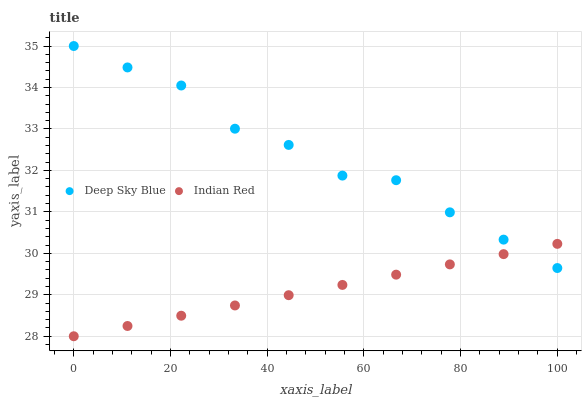Does Indian Red have the minimum area under the curve?
Answer yes or no. Yes. Does Deep Sky Blue have the maximum area under the curve?
Answer yes or no. Yes. Does Deep Sky Blue have the minimum area under the curve?
Answer yes or no. No. Is Indian Red the smoothest?
Answer yes or no. Yes. Is Deep Sky Blue the roughest?
Answer yes or no. Yes. Is Deep Sky Blue the smoothest?
Answer yes or no. No. Does Indian Red have the lowest value?
Answer yes or no. Yes. Does Deep Sky Blue have the lowest value?
Answer yes or no. No. Does Deep Sky Blue have the highest value?
Answer yes or no. Yes. Does Indian Red intersect Deep Sky Blue?
Answer yes or no. Yes. Is Indian Red less than Deep Sky Blue?
Answer yes or no. No. Is Indian Red greater than Deep Sky Blue?
Answer yes or no. No. 